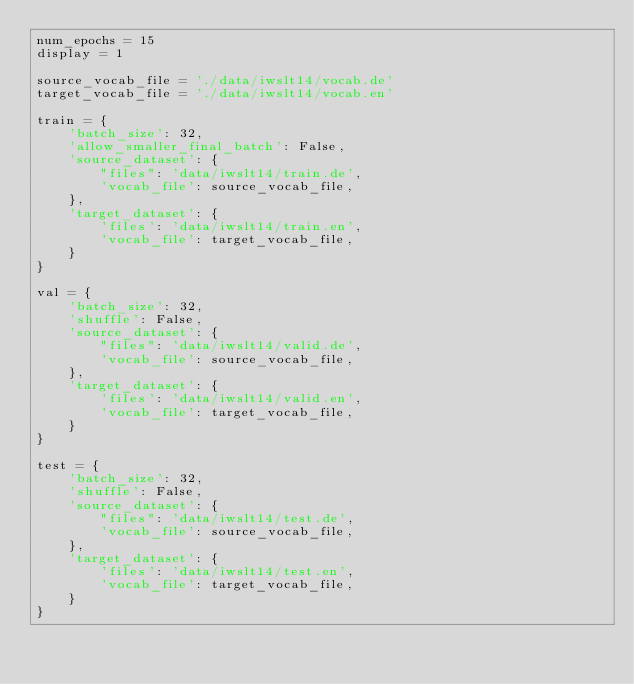Convert code to text. <code><loc_0><loc_0><loc_500><loc_500><_Python_>num_epochs = 15
display = 1

source_vocab_file = './data/iwslt14/vocab.de'
target_vocab_file = './data/iwslt14/vocab.en'

train = {
    'batch_size': 32,
    'allow_smaller_final_batch': False,
    'source_dataset': {
        "files": 'data/iwslt14/train.de',
        'vocab_file': source_vocab_file,
    },
    'target_dataset': {
        'files': 'data/iwslt14/train.en',
        'vocab_file': target_vocab_file,
    }
}

val = {
    'batch_size': 32,
    'shuffle': False,
    'source_dataset': {
        "files": 'data/iwslt14/valid.de',
        'vocab_file': source_vocab_file,
    },
    'target_dataset': {
        'files': 'data/iwslt14/valid.en',
        'vocab_file': target_vocab_file,
    }
}

test = {
    'batch_size': 32,
    'shuffle': False,
    'source_dataset': {
        "files": 'data/iwslt14/test.de',
        'vocab_file': source_vocab_file,
    },
    'target_dataset': {
        'files': 'data/iwslt14/test.en',
        'vocab_file': target_vocab_file,
    }
}
</code> 